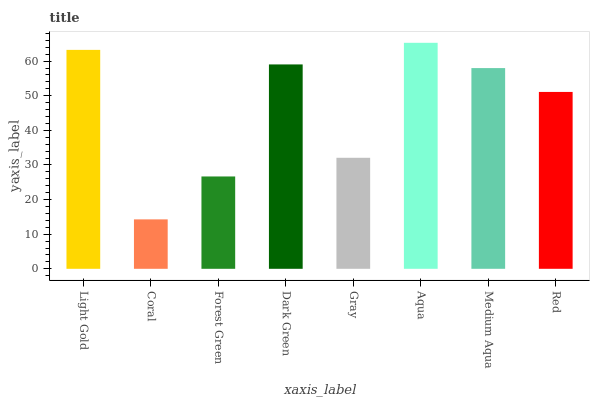Is Forest Green the minimum?
Answer yes or no. No. Is Forest Green the maximum?
Answer yes or no. No. Is Forest Green greater than Coral?
Answer yes or no. Yes. Is Coral less than Forest Green?
Answer yes or no. Yes. Is Coral greater than Forest Green?
Answer yes or no. No. Is Forest Green less than Coral?
Answer yes or no. No. Is Medium Aqua the high median?
Answer yes or no. Yes. Is Red the low median?
Answer yes or no. Yes. Is Coral the high median?
Answer yes or no. No. Is Coral the low median?
Answer yes or no. No. 